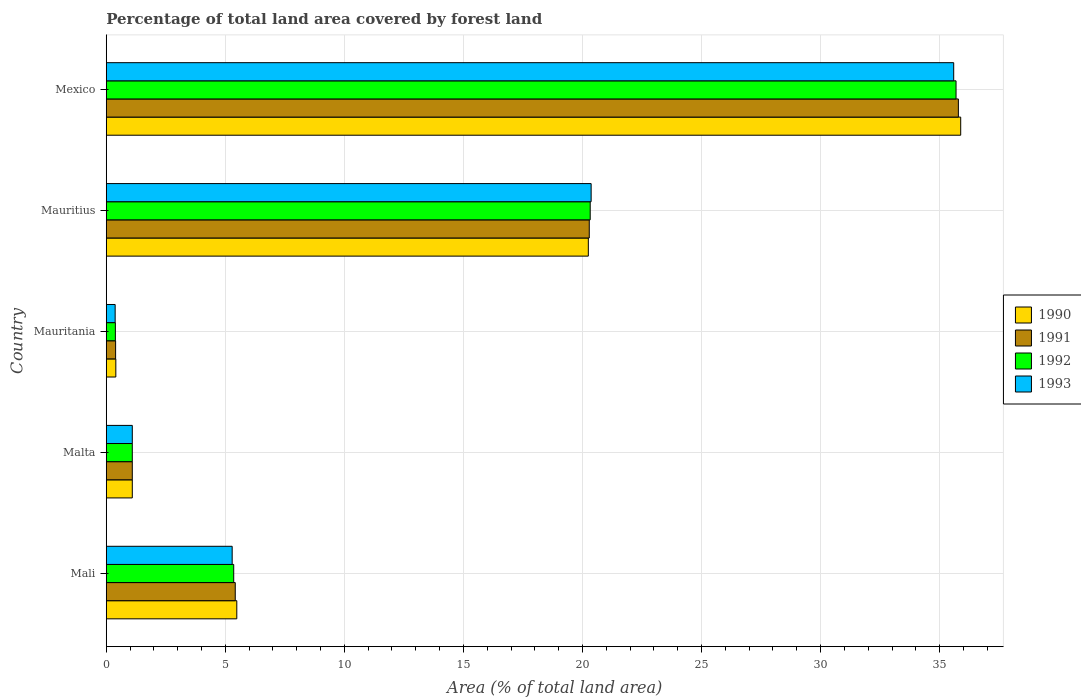How many different coloured bars are there?
Offer a very short reply. 4. Are the number of bars per tick equal to the number of legend labels?
Your answer should be compact. Yes. Are the number of bars on each tick of the Y-axis equal?
Provide a succinct answer. Yes. How many bars are there on the 4th tick from the top?
Your response must be concise. 4. How many bars are there on the 2nd tick from the bottom?
Your answer should be compact. 4. What is the label of the 4th group of bars from the top?
Ensure brevity in your answer.  Malta. What is the percentage of forest land in 1993 in Mauritania?
Your answer should be compact. 0.37. Across all countries, what is the maximum percentage of forest land in 1991?
Keep it short and to the point. 35.79. Across all countries, what is the minimum percentage of forest land in 1993?
Provide a short and direct response. 0.37. In which country was the percentage of forest land in 1990 minimum?
Give a very brief answer. Mauritania. What is the total percentage of forest land in 1991 in the graph?
Your answer should be compact. 62.98. What is the difference between the percentage of forest land in 1993 in Mauritius and that in Mexico?
Your answer should be compact. -15.23. What is the difference between the percentage of forest land in 1993 in Malta and the percentage of forest land in 1992 in Mexico?
Offer a very short reply. -34.6. What is the average percentage of forest land in 1992 per country?
Provide a short and direct response. 12.57. What is the difference between the percentage of forest land in 1992 and percentage of forest land in 1990 in Mali?
Keep it short and to the point. -0.13. In how many countries, is the percentage of forest land in 1990 greater than 5 %?
Your answer should be very brief. 3. What is the ratio of the percentage of forest land in 1992 in Mauritius to that in Mexico?
Keep it short and to the point. 0.57. Is the percentage of forest land in 1990 in Mali less than that in Mauritania?
Your response must be concise. No. What is the difference between the highest and the second highest percentage of forest land in 1990?
Keep it short and to the point. 15.64. What is the difference between the highest and the lowest percentage of forest land in 1993?
Keep it short and to the point. 35.22. In how many countries, is the percentage of forest land in 1990 greater than the average percentage of forest land in 1990 taken over all countries?
Keep it short and to the point. 2. Is the sum of the percentage of forest land in 1991 in Malta and Mexico greater than the maximum percentage of forest land in 1990 across all countries?
Offer a very short reply. Yes. What does the 4th bar from the top in Mauritius represents?
Give a very brief answer. 1990. What does the 2nd bar from the bottom in Malta represents?
Your response must be concise. 1991. How many bars are there?
Make the answer very short. 20. What is the difference between two consecutive major ticks on the X-axis?
Provide a succinct answer. 5. Does the graph contain any zero values?
Provide a succinct answer. No. Does the graph contain grids?
Keep it short and to the point. Yes. Where does the legend appear in the graph?
Provide a short and direct response. Center right. How many legend labels are there?
Offer a terse response. 4. What is the title of the graph?
Give a very brief answer. Percentage of total land area covered by forest land. What is the label or title of the X-axis?
Make the answer very short. Area (% of total land area). What is the label or title of the Y-axis?
Offer a terse response. Country. What is the Area (% of total land area) of 1990 in Mali?
Ensure brevity in your answer.  5.48. What is the Area (% of total land area) in 1991 in Mali?
Provide a succinct answer. 5.42. What is the Area (% of total land area) of 1992 in Mali?
Your answer should be compact. 5.35. What is the Area (% of total land area) in 1993 in Mali?
Keep it short and to the point. 5.29. What is the Area (% of total land area) of 1990 in Malta?
Your answer should be compact. 1.09. What is the Area (% of total land area) in 1991 in Malta?
Your answer should be very brief. 1.09. What is the Area (% of total land area) of 1992 in Malta?
Provide a short and direct response. 1.09. What is the Area (% of total land area) in 1993 in Malta?
Your answer should be very brief. 1.09. What is the Area (% of total land area) in 1990 in Mauritania?
Ensure brevity in your answer.  0.4. What is the Area (% of total land area) in 1991 in Mauritania?
Provide a short and direct response. 0.39. What is the Area (% of total land area) of 1992 in Mauritania?
Keep it short and to the point. 0.38. What is the Area (% of total land area) in 1993 in Mauritania?
Keep it short and to the point. 0.37. What is the Area (% of total land area) in 1990 in Mauritius?
Keep it short and to the point. 20.25. What is the Area (% of total land area) in 1991 in Mauritius?
Offer a very short reply. 20.29. What is the Area (% of total land area) of 1992 in Mauritius?
Give a very brief answer. 20.33. What is the Area (% of total land area) of 1993 in Mauritius?
Your answer should be very brief. 20.36. What is the Area (% of total land area) in 1990 in Mexico?
Provide a short and direct response. 35.89. What is the Area (% of total land area) in 1991 in Mexico?
Offer a very short reply. 35.79. What is the Area (% of total land area) of 1992 in Mexico?
Your answer should be compact. 35.69. What is the Area (% of total land area) in 1993 in Mexico?
Offer a very short reply. 35.59. Across all countries, what is the maximum Area (% of total land area) in 1990?
Your response must be concise. 35.89. Across all countries, what is the maximum Area (% of total land area) of 1991?
Offer a very short reply. 35.79. Across all countries, what is the maximum Area (% of total land area) in 1992?
Keep it short and to the point. 35.69. Across all countries, what is the maximum Area (% of total land area) of 1993?
Ensure brevity in your answer.  35.59. Across all countries, what is the minimum Area (% of total land area) in 1990?
Keep it short and to the point. 0.4. Across all countries, what is the minimum Area (% of total land area) of 1991?
Your answer should be very brief. 0.39. Across all countries, what is the minimum Area (% of total land area) of 1992?
Ensure brevity in your answer.  0.38. Across all countries, what is the minimum Area (% of total land area) in 1993?
Your answer should be very brief. 0.37. What is the total Area (% of total land area) of 1990 in the graph?
Your answer should be very brief. 63.11. What is the total Area (% of total land area) in 1991 in the graph?
Keep it short and to the point. 62.98. What is the total Area (% of total land area) of 1992 in the graph?
Provide a succinct answer. 62.85. What is the total Area (% of total land area) in 1993 in the graph?
Make the answer very short. 62.71. What is the difference between the Area (% of total land area) in 1990 in Mali and that in Malta?
Offer a terse response. 4.39. What is the difference between the Area (% of total land area) of 1991 in Mali and that in Malta?
Provide a succinct answer. 4.32. What is the difference between the Area (% of total land area) in 1992 in Mali and that in Malta?
Offer a very short reply. 4.26. What is the difference between the Area (% of total land area) of 1993 in Mali and that in Malta?
Your answer should be very brief. 4.19. What is the difference between the Area (% of total land area) in 1990 in Mali and that in Mauritania?
Keep it short and to the point. 5.08. What is the difference between the Area (% of total land area) in 1991 in Mali and that in Mauritania?
Your answer should be compact. 5.02. What is the difference between the Area (% of total land area) in 1992 in Mali and that in Mauritania?
Provide a succinct answer. 4.97. What is the difference between the Area (% of total land area) in 1993 in Mali and that in Mauritania?
Your response must be concise. 4.91. What is the difference between the Area (% of total land area) in 1990 in Mali and that in Mauritius?
Offer a terse response. -14.76. What is the difference between the Area (% of total land area) in 1991 in Mali and that in Mauritius?
Keep it short and to the point. -14.87. What is the difference between the Area (% of total land area) of 1992 in Mali and that in Mauritius?
Provide a short and direct response. -14.97. What is the difference between the Area (% of total land area) of 1993 in Mali and that in Mauritius?
Offer a very short reply. -15.08. What is the difference between the Area (% of total land area) of 1990 in Mali and that in Mexico?
Keep it short and to the point. -30.4. What is the difference between the Area (% of total land area) in 1991 in Mali and that in Mexico?
Offer a very short reply. -30.37. What is the difference between the Area (% of total land area) of 1992 in Mali and that in Mexico?
Make the answer very short. -30.34. What is the difference between the Area (% of total land area) of 1993 in Mali and that in Mexico?
Your answer should be very brief. -30.3. What is the difference between the Area (% of total land area) in 1990 in Malta and that in Mauritania?
Provide a succinct answer. 0.69. What is the difference between the Area (% of total land area) in 1991 in Malta and that in Mauritania?
Provide a succinct answer. 0.7. What is the difference between the Area (% of total land area) of 1992 in Malta and that in Mauritania?
Your answer should be compact. 0.71. What is the difference between the Area (% of total land area) of 1993 in Malta and that in Mauritania?
Give a very brief answer. 0.72. What is the difference between the Area (% of total land area) of 1990 in Malta and that in Mauritius?
Your response must be concise. -19.15. What is the difference between the Area (% of total land area) of 1991 in Malta and that in Mauritius?
Give a very brief answer. -19.19. What is the difference between the Area (% of total land area) of 1992 in Malta and that in Mauritius?
Your answer should be very brief. -19.23. What is the difference between the Area (% of total land area) in 1993 in Malta and that in Mauritius?
Ensure brevity in your answer.  -19.27. What is the difference between the Area (% of total land area) in 1990 in Malta and that in Mexico?
Provide a succinct answer. -34.79. What is the difference between the Area (% of total land area) of 1991 in Malta and that in Mexico?
Your response must be concise. -34.69. What is the difference between the Area (% of total land area) of 1992 in Malta and that in Mexico?
Your answer should be compact. -34.6. What is the difference between the Area (% of total land area) in 1993 in Malta and that in Mexico?
Your answer should be compact. -34.5. What is the difference between the Area (% of total land area) in 1990 in Mauritania and that in Mauritius?
Your response must be concise. -19.84. What is the difference between the Area (% of total land area) in 1991 in Mauritania and that in Mauritius?
Give a very brief answer. -19.89. What is the difference between the Area (% of total land area) of 1992 in Mauritania and that in Mauritius?
Give a very brief answer. -19.94. What is the difference between the Area (% of total land area) in 1993 in Mauritania and that in Mauritius?
Keep it short and to the point. -19.99. What is the difference between the Area (% of total land area) of 1990 in Mauritania and that in Mexico?
Provide a succinct answer. -35.48. What is the difference between the Area (% of total land area) in 1991 in Mauritania and that in Mexico?
Offer a very short reply. -35.39. What is the difference between the Area (% of total land area) of 1992 in Mauritania and that in Mexico?
Offer a terse response. -35.31. What is the difference between the Area (% of total land area) in 1993 in Mauritania and that in Mexico?
Ensure brevity in your answer.  -35.22. What is the difference between the Area (% of total land area) in 1990 in Mauritius and that in Mexico?
Your answer should be very brief. -15.64. What is the difference between the Area (% of total land area) in 1991 in Mauritius and that in Mexico?
Your answer should be compact. -15.5. What is the difference between the Area (% of total land area) of 1992 in Mauritius and that in Mexico?
Ensure brevity in your answer.  -15.36. What is the difference between the Area (% of total land area) in 1993 in Mauritius and that in Mexico?
Your answer should be very brief. -15.23. What is the difference between the Area (% of total land area) in 1990 in Mali and the Area (% of total land area) in 1991 in Malta?
Make the answer very short. 4.39. What is the difference between the Area (% of total land area) in 1990 in Mali and the Area (% of total land area) in 1992 in Malta?
Keep it short and to the point. 4.39. What is the difference between the Area (% of total land area) of 1990 in Mali and the Area (% of total land area) of 1993 in Malta?
Your response must be concise. 4.39. What is the difference between the Area (% of total land area) of 1991 in Mali and the Area (% of total land area) of 1992 in Malta?
Make the answer very short. 4.32. What is the difference between the Area (% of total land area) in 1991 in Mali and the Area (% of total land area) in 1993 in Malta?
Keep it short and to the point. 4.32. What is the difference between the Area (% of total land area) of 1992 in Mali and the Area (% of total land area) of 1993 in Malta?
Your response must be concise. 4.26. What is the difference between the Area (% of total land area) in 1990 in Mali and the Area (% of total land area) in 1991 in Mauritania?
Offer a very short reply. 5.09. What is the difference between the Area (% of total land area) in 1990 in Mali and the Area (% of total land area) in 1992 in Mauritania?
Offer a terse response. 5.1. What is the difference between the Area (% of total land area) in 1990 in Mali and the Area (% of total land area) in 1993 in Mauritania?
Offer a terse response. 5.11. What is the difference between the Area (% of total land area) in 1991 in Mali and the Area (% of total land area) in 1992 in Mauritania?
Your answer should be compact. 5.03. What is the difference between the Area (% of total land area) in 1991 in Mali and the Area (% of total land area) in 1993 in Mauritania?
Your answer should be very brief. 5.04. What is the difference between the Area (% of total land area) in 1992 in Mali and the Area (% of total land area) in 1993 in Mauritania?
Make the answer very short. 4.98. What is the difference between the Area (% of total land area) in 1990 in Mali and the Area (% of total land area) in 1991 in Mauritius?
Provide a succinct answer. -14.8. What is the difference between the Area (% of total land area) in 1990 in Mali and the Area (% of total land area) in 1992 in Mauritius?
Your answer should be compact. -14.84. What is the difference between the Area (% of total land area) of 1990 in Mali and the Area (% of total land area) of 1993 in Mauritius?
Offer a very short reply. -14.88. What is the difference between the Area (% of total land area) of 1991 in Mali and the Area (% of total land area) of 1992 in Mauritius?
Offer a very short reply. -14.91. What is the difference between the Area (% of total land area) of 1991 in Mali and the Area (% of total land area) of 1993 in Mauritius?
Your response must be concise. -14.95. What is the difference between the Area (% of total land area) in 1992 in Mali and the Area (% of total land area) in 1993 in Mauritius?
Provide a succinct answer. -15.01. What is the difference between the Area (% of total land area) of 1990 in Mali and the Area (% of total land area) of 1991 in Mexico?
Make the answer very short. -30.3. What is the difference between the Area (% of total land area) of 1990 in Mali and the Area (% of total land area) of 1992 in Mexico?
Ensure brevity in your answer.  -30.21. What is the difference between the Area (% of total land area) in 1990 in Mali and the Area (% of total land area) in 1993 in Mexico?
Offer a terse response. -30.11. What is the difference between the Area (% of total land area) in 1991 in Mali and the Area (% of total land area) in 1992 in Mexico?
Provide a succinct answer. -30.27. What is the difference between the Area (% of total land area) in 1991 in Mali and the Area (% of total land area) in 1993 in Mexico?
Provide a succinct answer. -30.17. What is the difference between the Area (% of total land area) in 1992 in Mali and the Area (% of total land area) in 1993 in Mexico?
Ensure brevity in your answer.  -30.24. What is the difference between the Area (% of total land area) in 1990 in Malta and the Area (% of total land area) in 1991 in Mauritania?
Offer a very short reply. 0.7. What is the difference between the Area (% of total land area) in 1990 in Malta and the Area (% of total land area) in 1992 in Mauritania?
Keep it short and to the point. 0.71. What is the difference between the Area (% of total land area) in 1990 in Malta and the Area (% of total land area) in 1993 in Mauritania?
Make the answer very short. 0.72. What is the difference between the Area (% of total land area) in 1991 in Malta and the Area (% of total land area) in 1992 in Mauritania?
Make the answer very short. 0.71. What is the difference between the Area (% of total land area) in 1991 in Malta and the Area (% of total land area) in 1993 in Mauritania?
Ensure brevity in your answer.  0.72. What is the difference between the Area (% of total land area) of 1992 in Malta and the Area (% of total land area) of 1993 in Mauritania?
Your answer should be very brief. 0.72. What is the difference between the Area (% of total land area) of 1990 in Malta and the Area (% of total land area) of 1991 in Mauritius?
Ensure brevity in your answer.  -19.19. What is the difference between the Area (% of total land area) in 1990 in Malta and the Area (% of total land area) in 1992 in Mauritius?
Make the answer very short. -19.23. What is the difference between the Area (% of total land area) in 1990 in Malta and the Area (% of total land area) in 1993 in Mauritius?
Give a very brief answer. -19.27. What is the difference between the Area (% of total land area) in 1991 in Malta and the Area (% of total land area) in 1992 in Mauritius?
Your answer should be very brief. -19.23. What is the difference between the Area (% of total land area) in 1991 in Malta and the Area (% of total land area) in 1993 in Mauritius?
Keep it short and to the point. -19.27. What is the difference between the Area (% of total land area) of 1992 in Malta and the Area (% of total land area) of 1993 in Mauritius?
Ensure brevity in your answer.  -19.27. What is the difference between the Area (% of total land area) of 1990 in Malta and the Area (% of total land area) of 1991 in Mexico?
Ensure brevity in your answer.  -34.69. What is the difference between the Area (% of total land area) of 1990 in Malta and the Area (% of total land area) of 1992 in Mexico?
Your response must be concise. -34.6. What is the difference between the Area (% of total land area) of 1990 in Malta and the Area (% of total land area) of 1993 in Mexico?
Make the answer very short. -34.5. What is the difference between the Area (% of total land area) of 1991 in Malta and the Area (% of total land area) of 1992 in Mexico?
Your answer should be very brief. -34.6. What is the difference between the Area (% of total land area) of 1991 in Malta and the Area (% of total land area) of 1993 in Mexico?
Offer a very short reply. -34.5. What is the difference between the Area (% of total land area) of 1992 in Malta and the Area (% of total land area) of 1993 in Mexico?
Keep it short and to the point. -34.5. What is the difference between the Area (% of total land area) in 1990 in Mauritania and the Area (% of total land area) in 1991 in Mauritius?
Give a very brief answer. -19.88. What is the difference between the Area (% of total land area) in 1990 in Mauritania and the Area (% of total land area) in 1992 in Mauritius?
Offer a terse response. -19.92. What is the difference between the Area (% of total land area) of 1990 in Mauritania and the Area (% of total land area) of 1993 in Mauritius?
Ensure brevity in your answer.  -19.96. What is the difference between the Area (% of total land area) in 1991 in Mauritania and the Area (% of total land area) in 1992 in Mauritius?
Offer a terse response. -19.93. What is the difference between the Area (% of total land area) in 1991 in Mauritania and the Area (% of total land area) in 1993 in Mauritius?
Give a very brief answer. -19.97. What is the difference between the Area (% of total land area) of 1992 in Mauritania and the Area (% of total land area) of 1993 in Mauritius?
Offer a very short reply. -19.98. What is the difference between the Area (% of total land area) in 1990 in Mauritania and the Area (% of total land area) in 1991 in Mexico?
Keep it short and to the point. -35.39. What is the difference between the Area (% of total land area) of 1990 in Mauritania and the Area (% of total land area) of 1992 in Mexico?
Keep it short and to the point. -35.29. What is the difference between the Area (% of total land area) of 1990 in Mauritania and the Area (% of total land area) of 1993 in Mexico?
Give a very brief answer. -35.19. What is the difference between the Area (% of total land area) of 1991 in Mauritania and the Area (% of total land area) of 1992 in Mexico?
Your response must be concise. -35.3. What is the difference between the Area (% of total land area) of 1991 in Mauritania and the Area (% of total land area) of 1993 in Mexico?
Give a very brief answer. -35.2. What is the difference between the Area (% of total land area) of 1992 in Mauritania and the Area (% of total land area) of 1993 in Mexico?
Offer a very short reply. -35.21. What is the difference between the Area (% of total land area) of 1990 in Mauritius and the Area (% of total land area) of 1991 in Mexico?
Ensure brevity in your answer.  -15.54. What is the difference between the Area (% of total land area) in 1990 in Mauritius and the Area (% of total land area) in 1992 in Mexico?
Your answer should be compact. -15.44. What is the difference between the Area (% of total land area) of 1990 in Mauritius and the Area (% of total land area) of 1993 in Mexico?
Offer a very short reply. -15.35. What is the difference between the Area (% of total land area) in 1991 in Mauritius and the Area (% of total land area) in 1992 in Mexico?
Your answer should be compact. -15.4. What is the difference between the Area (% of total land area) in 1991 in Mauritius and the Area (% of total land area) in 1993 in Mexico?
Give a very brief answer. -15.31. What is the difference between the Area (% of total land area) in 1992 in Mauritius and the Area (% of total land area) in 1993 in Mexico?
Ensure brevity in your answer.  -15.27. What is the average Area (% of total land area) in 1990 per country?
Your answer should be compact. 12.62. What is the average Area (% of total land area) of 1991 per country?
Make the answer very short. 12.6. What is the average Area (% of total land area) in 1992 per country?
Give a very brief answer. 12.57. What is the average Area (% of total land area) of 1993 per country?
Offer a terse response. 12.54. What is the difference between the Area (% of total land area) in 1990 and Area (% of total land area) in 1991 in Mali?
Ensure brevity in your answer.  0.06. What is the difference between the Area (% of total land area) of 1990 and Area (% of total land area) of 1992 in Mali?
Your response must be concise. 0.13. What is the difference between the Area (% of total land area) of 1990 and Area (% of total land area) of 1993 in Mali?
Your answer should be very brief. 0.19. What is the difference between the Area (% of total land area) of 1991 and Area (% of total land area) of 1992 in Mali?
Give a very brief answer. 0.06. What is the difference between the Area (% of total land area) of 1991 and Area (% of total land area) of 1993 in Mali?
Give a very brief answer. 0.13. What is the difference between the Area (% of total land area) in 1992 and Area (% of total land area) in 1993 in Mali?
Provide a short and direct response. 0.06. What is the difference between the Area (% of total land area) in 1990 and Area (% of total land area) in 1992 in Malta?
Your response must be concise. 0. What is the difference between the Area (% of total land area) of 1991 and Area (% of total land area) of 1992 in Malta?
Your response must be concise. 0. What is the difference between the Area (% of total land area) in 1990 and Area (% of total land area) in 1991 in Mauritania?
Your answer should be compact. 0.01. What is the difference between the Area (% of total land area) of 1990 and Area (% of total land area) of 1992 in Mauritania?
Offer a terse response. 0.02. What is the difference between the Area (% of total land area) of 1990 and Area (% of total land area) of 1993 in Mauritania?
Provide a succinct answer. 0.03. What is the difference between the Area (% of total land area) of 1991 and Area (% of total land area) of 1992 in Mauritania?
Your answer should be very brief. 0.01. What is the difference between the Area (% of total land area) in 1991 and Area (% of total land area) in 1993 in Mauritania?
Give a very brief answer. 0.02. What is the difference between the Area (% of total land area) of 1992 and Area (% of total land area) of 1993 in Mauritania?
Offer a very short reply. 0.01. What is the difference between the Area (% of total land area) in 1990 and Area (% of total land area) in 1991 in Mauritius?
Make the answer very short. -0.04. What is the difference between the Area (% of total land area) of 1990 and Area (% of total land area) of 1992 in Mauritius?
Provide a succinct answer. -0.08. What is the difference between the Area (% of total land area) of 1990 and Area (% of total land area) of 1993 in Mauritius?
Provide a short and direct response. -0.12. What is the difference between the Area (% of total land area) of 1991 and Area (% of total land area) of 1992 in Mauritius?
Give a very brief answer. -0.04. What is the difference between the Area (% of total land area) of 1991 and Area (% of total land area) of 1993 in Mauritius?
Ensure brevity in your answer.  -0.08. What is the difference between the Area (% of total land area) in 1992 and Area (% of total land area) in 1993 in Mauritius?
Your response must be concise. -0.04. What is the difference between the Area (% of total land area) in 1990 and Area (% of total land area) in 1991 in Mexico?
Your response must be concise. 0.1. What is the difference between the Area (% of total land area) in 1990 and Area (% of total land area) in 1992 in Mexico?
Your answer should be very brief. 0.2. What is the difference between the Area (% of total land area) in 1990 and Area (% of total land area) in 1993 in Mexico?
Make the answer very short. 0.29. What is the difference between the Area (% of total land area) of 1991 and Area (% of total land area) of 1992 in Mexico?
Provide a succinct answer. 0.1. What is the difference between the Area (% of total land area) in 1991 and Area (% of total land area) in 1993 in Mexico?
Keep it short and to the point. 0.2. What is the difference between the Area (% of total land area) of 1992 and Area (% of total land area) of 1993 in Mexico?
Offer a very short reply. 0.1. What is the ratio of the Area (% of total land area) in 1990 in Mali to that in Malta?
Offer a very short reply. 5.01. What is the ratio of the Area (% of total land area) of 1991 in Mali to that in Malta?
Ensure brevity in your answer.  4.95. What is the ratio of the Area (% of total land area) of 1992 in Mali to that in Malta?
Your response must be concise. 4.89. What is the ratio of the Area (% of total land area) in 1993 in Mali to that in Malta?
Keep it short and to the point. 4.84. What is the ratio of the Area (% of total land area) of 1990 in Mali to that in Mauritania?
Offer a very short reply. 13.62. What is the ratio of the Area (% of total land area) of 1991 in Mali to that in Mauritania?
Your answer should be compact. 13.78. What is the ratio of the Area (% of total land area) in 1992 in Mali to that in Mauritania?
Give a very brief answer. 13.95. What is the ratio of the Area (% of total land area) of 1993 in Mali to that in Mauritania?
Your answer should be very brief. 14.14. What is the ratio of the Area (% of total land area) of 1990 in Mali to that in Mauritius?
Provide a succinct answer. 0.27. What is the ratio of the Area (% of total land area) in 1991 in Mali to that in Mauritius?
Your answer should be compact. 0.27. What is the ratio of the Area (% of total land area) of 1992 in Mali to that in Mauritius?
Keep it short and to the point. 0.26. What is the ratio of the Area (% of total land area) of 1993 in Mali to that in Mauritius?
Your answer should be compact. 0.26. What is the ratio of the Area (% of total land area) in 1990 in Mali to that in Mexico?
Your answer should be compact. 0.15. What is the ratio of the Area (% of total land area) in 1991 in Mali to that in Mexico?
Your response must be concise. 0.15. What is the ratio of the Area (% of total land area) of 1992 in Mali to that in Mexico?
Your response must be concise. 0.15. What is the ratio of the Area (% of total land area) in 1993 in Mali to that in Mexico?
Provide a succinct answer. 0.15. What is the ratio of the Area (% of total land area) in 1990 in Malta to that in Mauritania?
Keep it short and to the point. 2.72. What is the ratio of the Area (% of total land area) in 1991 in Malta to that in Mauritania?
Your response must be concise. 2.78. What is the ratio of the Area (% of total land area) of 1992 in Malta to that in Mauritania?
Your answer should be very brief. 2.85. What is the ratio of the Area (% of total land area) of 1993 in Malta to that in Mauritania?
Provide a succinct answer. 2.92. What is the ratio of the Area (% of total land area) of 1990 in Malta to that in Mauritius?
Give a very brief answer. 0.05. What is the ratio of the Area (% of total land area) in 1991 in Malta to that in Mauritius?
Your response must be concise. 0.05. What is the ratio of the Area (% of total land area) in 1992 in Malta to that in Mauritius?
Ensure brevity in your answer.  0.05. What is the ratio of the Area (% of total land area) in 1993 in Malta to that in Mauritius?
Your response must be concise. 0.05. What is the ratio of the Area (% of total land area) of 1990 in Malta to that in Mexico?
Your answer should be very brief. 0.03. What is the ratio of the Area (% of total land area) in 1991 in Malta to that in Mexico?
Provide a short and direct response. 0.03. What is the ratio of the Area (% of total land area) in 1992 in Malta to that in Mexico?
Make the answer very short. 0.03. What is the ratio of the Area (% of total land area) of 1993 in Malta to that in Mexico?
Your answer should be very brief. 0.03. What is the ratio of the Area (% of total land area) of 1990 in Mauritania to that in Mauritius?
Your answer should be very brief. 0.02. What is the ratio of the Area (% of total land area) of 1991 in Mauritania to that in Mauritius?
Keep it short and to the point. 0.02. What is the ratio of the Area (% of total land area) in 1992 in Mauritania to that in Mauritius?
Offer a very short reply. 0.02. What is the ratio of the Area (% of total land area) in 1993 in Mauritania to that in Mauritius?
Keep it short and to the point. 0.02. What is the ratio of the Area (% of total land area) in 1990 in Mauritania to that in Mexico?
Your answer should be compact. 0.01. What is the ratio of the Area (% of total land area) of 1991 in Mauritania to that in Mexico?
Provide a short and direct response. 0.01. What is the ratio of the Area (% of total land area) in 1992 in Mauritania to that in Mexico?
Keep it short and to the point. 0.01. What is the ratio of the Area (% of total land area) of 1993 in Mauritania to that in Mexico?
Make the answer very short. 0.01. What is the ratio of the Area (% of total land area) in 1990 in Mauritius to that in Mexico?
Your answer should be very brief. 0.56. What is the ratio of the Area (% of total land area) of 1991 in Mauritius to that in Mexico?
Offer a terse response. 0.57. What is the ratio of the Area (% of total land area) in 1992 in Mauritius to that in Mexico?
Ensure brevity in your answer.  0.57. What is the ratio of the Area (% of total land area) of 1993 in Mauritius to that in Mexico?
Your response must be concise. 0.57. What is the difference between the highest and the second highest Area (% of total land area) in 1990?
Ensure brevity in your answer.  15.64. What is the difference between the highest and the second highest Area (% of total land area) in 1991?
Make the answer very short. 15.5. What is the difference between the highest and the second highest Area (% of total land area) in 1992?
Provide a succinct answer. 15.36. What is the difference between the highest and the second highest Area (% of total land area) in 1993?
Make the answer very short. 15.23. What is the difference between the highest and the lowest Area (% of total land area) in 1990?
Your answer should be very brief. 35.48. What is the difference between the highest and the lowest Area (% of total land area) in 1991?
Your answer should be very brief. 35.39. What is the difference between the highest and the lowest Area (% of total land area) of 1992?
Provide a short and direct response. 35.31. What is the difference between the highest and the lowest Area (% of total land area) of 1993?
Your answer should be very brief. 35.22. 